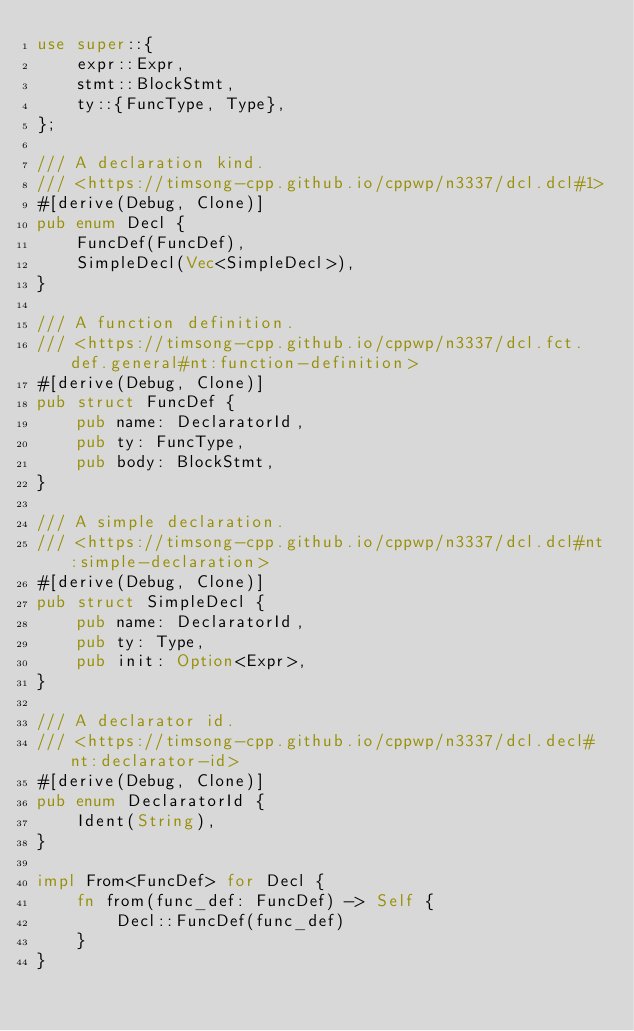Convert code to text. <code><loc_0><loc_0><loc_500><loc_500><_Rust_>use super::{
    expr::Expr,
    stmt::BlockStmt,
    ty::{FuncType, Type},
};

/// A declaration kind.
/// <https://timsong-cpp.github.io/cppwp/n3337/dcl.dcl#1>
#[derive(Debug, Clone)]
pub enum Decl {
    FuncDef(FuncDef),
    SimpleDecl(Vec<SimpleDecl>),
}

/// A function definition.
/// <https://timsong-cpp.github.io/cppwp/n3337/dcl.fct.def.general#nt:function-definition>
#[derive(Debug, Clone)]
pub struct FuncDef {
    pub name: DeclaratorId,
    pub ty: FuncType,
    pub body: BlockStmt,
}

/// A simple declaration.
/// <https://timsong-cpp.github.io/cppwp/n3337/dcl.dcl#nt:simple-declaration>
#[derive(Debug, Clone)]
pub struct SimpleDecl {
    pub name: DeclaratorId,
    pub ty: Type,
    pub init: Option<Expr>,
}

/// A declarator id.
/// <https://timsong-cpp.github.io/cppwp/n3337/dcl.decl#nt:declarator-id>
#[derive(Debug, Clone)]
pub enum DeclaratorId {
    Ident(String),
}

impl From<FuncDef> for Decl {
    fn from(func_def: FuncDef) -> Self {
        Decl::FuncDef(func_def)
    }
}
</code> 